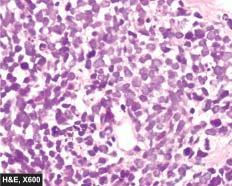what are small, uniform, lymphocyte-like with scanty cytoplasm?
Answer the question using a single word or phrase. Individual tumour cells 